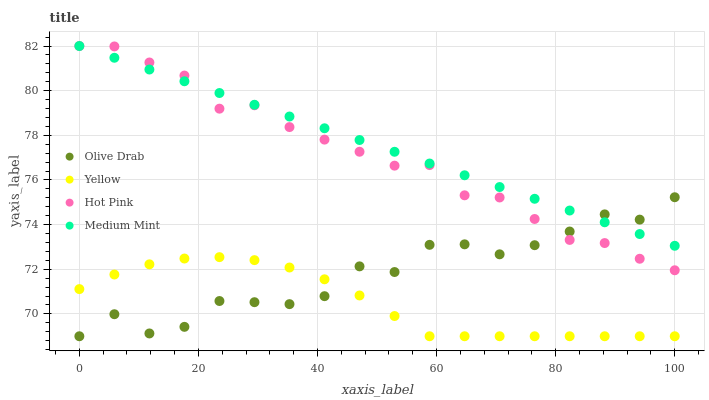Does Yellow have the minimum area under the curve?
Answer yes or no. Yes. Does Medium Mint have the maximum area under the curve?
Answer yes or no. Yes. Does Hot Pink have the minimum area under the curve?
Answer yes or no. No. Does Hot Pink have the maximum area under the curve?
Answer yes or no. No. Is Medium Mint the smoothest?
Answer yes or no. Yes. Is Olive Drab the roughest?
Answer yes or no. Yes. Is Hot Pink the smoothest?
Answer yes or no. No. Is Hot Pink the roughest?
Answer yes or no. No. Does Yellow have the lowest value?
Answer yes or no. Yes. Does Hot Pink have the lowest value?
Answer yes or no. No. Does Hot Pink have the highest value?
Answer yes or no. Yes. Does Yellow have the highest value?
Answer yes or no. No. Is Yellow less than Hot Pink?
Answer yes or no. Yes. Is Medium Mint greater than Yellow?
Answer yes or no. Yes. Does Olive Drab intersect Medium Mint?
Answer yes or no. Yes. Is Olive Drab less than Medium Mint?
Answer yes or no. No. Is Olive Drab greater than Medium Mint?
Answer yes or no. No. Does Yellow intersect Hot Pink?
Answer yes or no. No. 